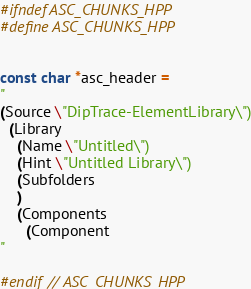Convert code to text. <code><loc_0><loc_0><loc_500><loc_500><_C++_>#ifndef ASC_CHUNKS_HPP
#define ASC_CHUNKS_HPP


const char *asc_header =
"
(Source \"DipTrace-ElementLibrary\")
  (Library
    (Name \"Untitled\")
    (Hint \"Untitled Library\")
    (Subfolders
    )
    (Components
      (Component
"

#endif // ASC_CHUNKS_HPP
</code> 